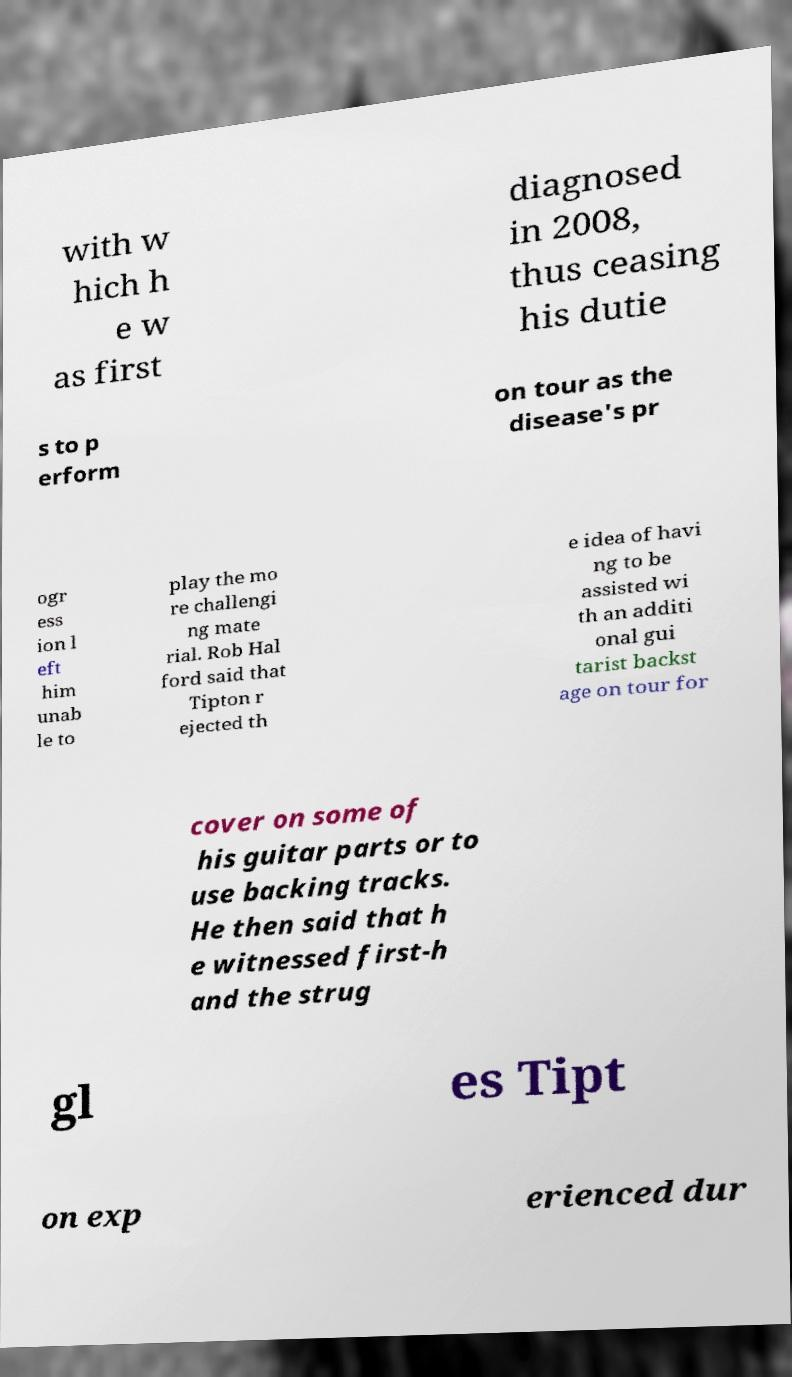For documentation purposes, I need the text within this image transcribed. Could you provide that? with w hich h e w as first diagnosed in 2008, thus ceasing his dutie s to p erform on tour as the disease's pr ogr ess ion l eft him unab le to play the mo re challengi ng mate rial. Rob Hal ford said that Tipton r ejected th e idea of havi ng to be assisted wi th an additi onal gui tarist backst age on tour for cover on some of his guitar parts or to use backing tracks. He then said that h e witnessed first-h and the strug gl es Tipt on exp erienced dur 